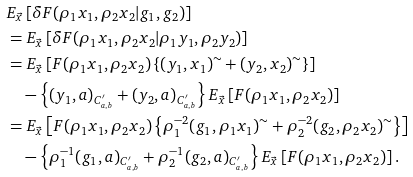<formula> <loc_0><loc_0><loc_500><loc_500>& E _ { \vec { x } } \left [ \delta F ( \rho _ { 1 } x _ { 1 } , \rho _ { 2 } x _ { 2 } | g _ { 1 } , g _ { 2 } ) \right ] \\ & = E _ { \vec { x } } \left [ \delta F ( \rho _ { 1 } x _ { 1 } , \rho _ { 2 } x _ { 2 } | \rho _ { 1 } y _ { 1 } , \rho _ { 2 } y _ { 2 } ) \right ] \\ & = E _ { \vec { x } } \left [ F ( \rho _ { 1 } x _ { 1 } , \rho _ { 2 } x _ { 2 } ) \left \{ ( y _ { 1 } , x _ { 1 } ) ^ { \sim } + ( y _ { 2 } , x _ { 2 } ) ^ { \sim } \right \} \right ] \\ & \quad - \left \{ ( y _ { 1 } , a ) _ { C _ { a , b } ^ { \prime } } + ( y _ { 2 } , a ) _ { C _ { a , b } ^ { \prime } } \right \} E _ { \vec { x } } \left [ F ( \rho _ { 1 } x _ { 1 } , \rho _ { 2 } x _ { 2 } ) \right ] \\ & = E _ { \vec { x } } \left [ F ( \rho _ { 1 } x _ { 1 } , \rho _ { 2 } x _ { 2 } ) \left \{ \rho _ { 1 } ^ { - 2 } ( g _ { 1 } , \rho _ { 1 } x _ { 1 } ) ^ { \sim } + \rho _ { 2 } ^ { - 2 } ( g _ { 2 } , \rho _ { 2 } x _ { 2 } ) ^ { \sim } \right \} \right ] \\ & \quad - \left \{ \rho _ { 1 } ^ { - 1 } ( g _ { 1 } , a ) _ { C _ { a , b } ^ { \prime } } + \rho _ { 2 } ^ { - 1 } ( g _ { 2 } , a ) _ { C _ { a , b } ^ { \prime } } \right \} E _ { \vec { x } } \left [ F ( \rho _ { 1 } x _ { 1 } , \rho _ { 2 } x _ { 2 } ) \right ] .</formula> 